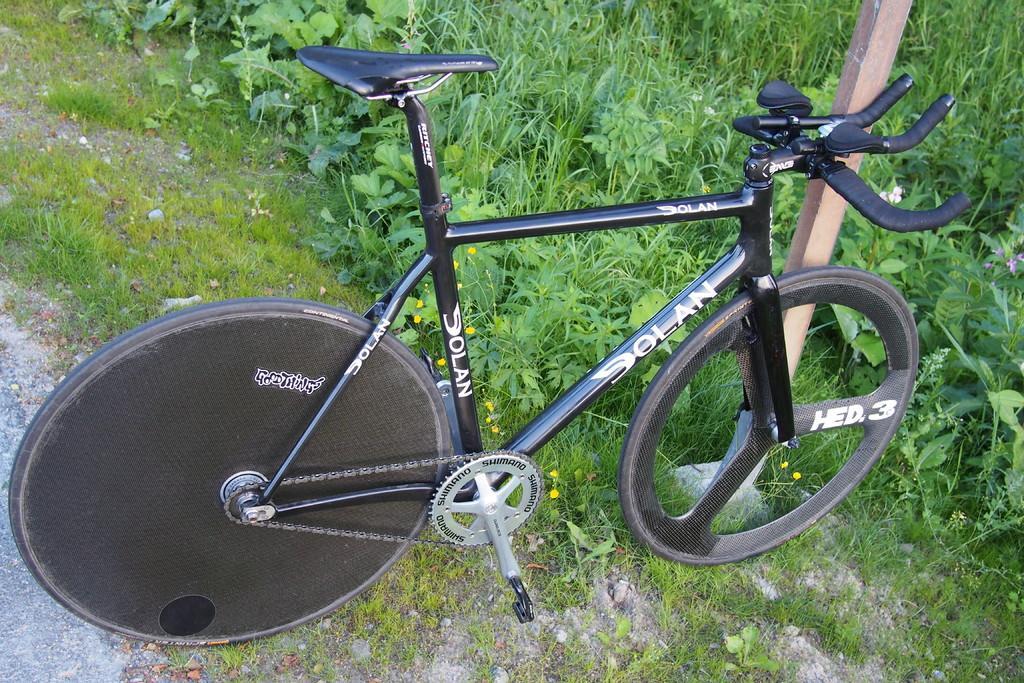Could you give a brief overview of what you see in this image? This picture is taken from the outside of the city. In this image, in the middle, we can see a bicycle, which is in black color. In the background, we can see some plants and grass. At the bottom, we can see a grass and a plant. 